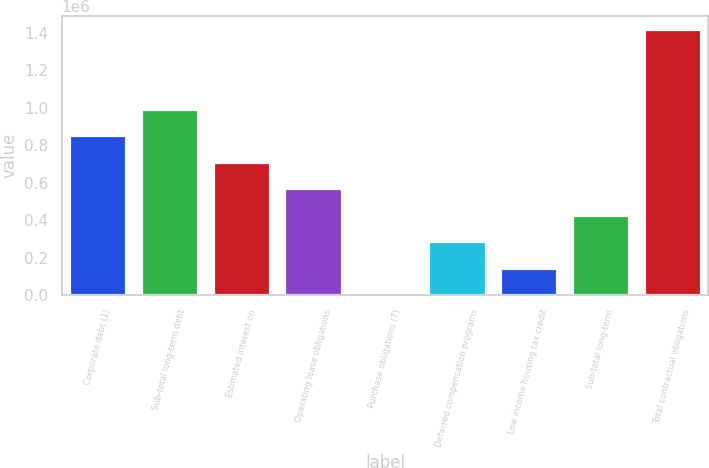<chart> <loc_0><loc_0><loc_500><loc_500><bar_chart><fcel>Corporate debt (1)<fcel>Sub-total long-term debt<fcel>Estimated interest on<fcel>Operating lease obligations<fcel>Purchase obligations (7)<fcel>Deferred compensation programs<fcel>Low income housing tax credit<fcel>Sub-total long-term<fcel>Total contractual obligations<nl><fcel>852755<fcel>994312<fcel>711197<fcel>569639<fcel>3409<fcel>286524<fcel>144967<fcel>428082<fcel>1.41898e+06<nl></chart> 